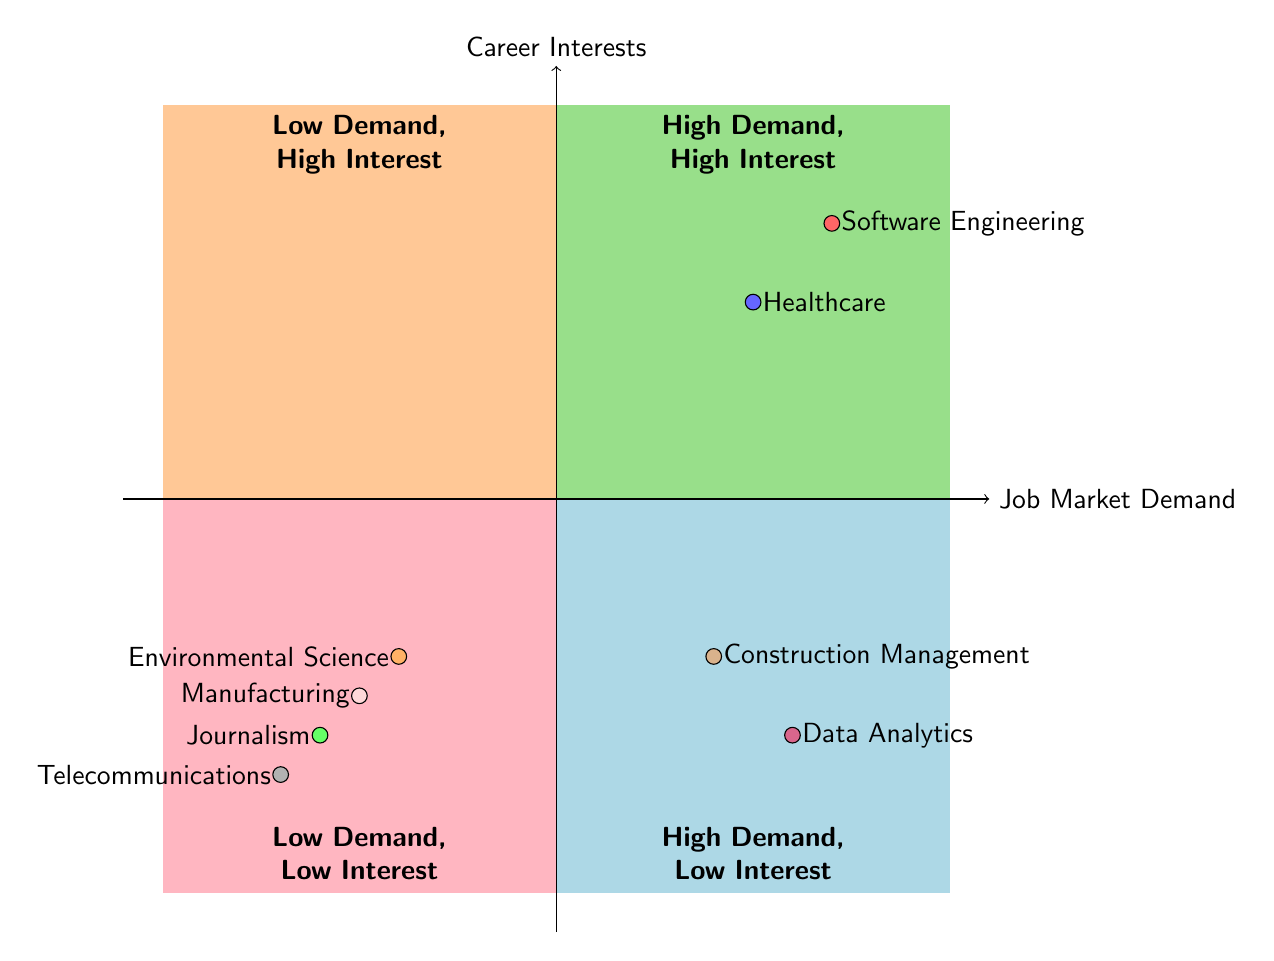What careers are in the High Demand, High Interest quadrant? The High Demand, High Interest quadrant includes Software Engineering and Healthcare based on the provided data. These careers have both high market demand and high interest.
Answer: Software Engineering, Healthcare How many careers are in the Low Demand, Low Interest quadrant? The Low Demand, Low Interest quadrant lists two careers: Telecommunications and Manufacturing. Thus, there are a total of two careers in this quadrant.
Answer: 2 Which career has High Demand and Low Interest? In the diagram, Data Analytics and Construction Management belong to the High Demand, Low Interest quadrant, indicating they have high market demand but low interest levels.
Answer: Data Analytics, Construction Management In which quadrant is Journalism located? Journalism is positioned in the Low Demand, High Interest quadrant, indicating it has low market demand but high interest from individuals pursuing this career.
Answer: Low Demand, High Interest What is the job market demand for Environmental Science? The job market demand for Environmental Science is low, as shown in its placement in the Low Demand, High Interest quadrant.
Answer: Low Which quadrant contains the most examples of careers? The High Demand, High Interest quadrant contains the most examples of careers, with both Software Engineering and Healthcare clearly listed in that area.
Answer: High Demand, High Interest How many quadrants are represented in this chart? The chart consists of four distinct quadrants: High Demand, High Interest; Low Demand, High Interest; High Demand, Low Interest; and Low Demand, Low Interest. Thus, the total number of quadrants is four.
Answer: 4 Which career example appears in the Low Demand, High Interest quadrant? In the Low Demand, High Interest quadrant, the career example of Journalism appears along with Environmental Science, indicating both have low demand yet high interest.
Answer: Journalism What are the examples listed for Data Analytics? Data Analytics has three examples provided: Accenture, IBM, and Deloitte, showcasing companies known for hiring in this field despite the low interest noted.
Answer: Accenture, IBM, Deloitte 